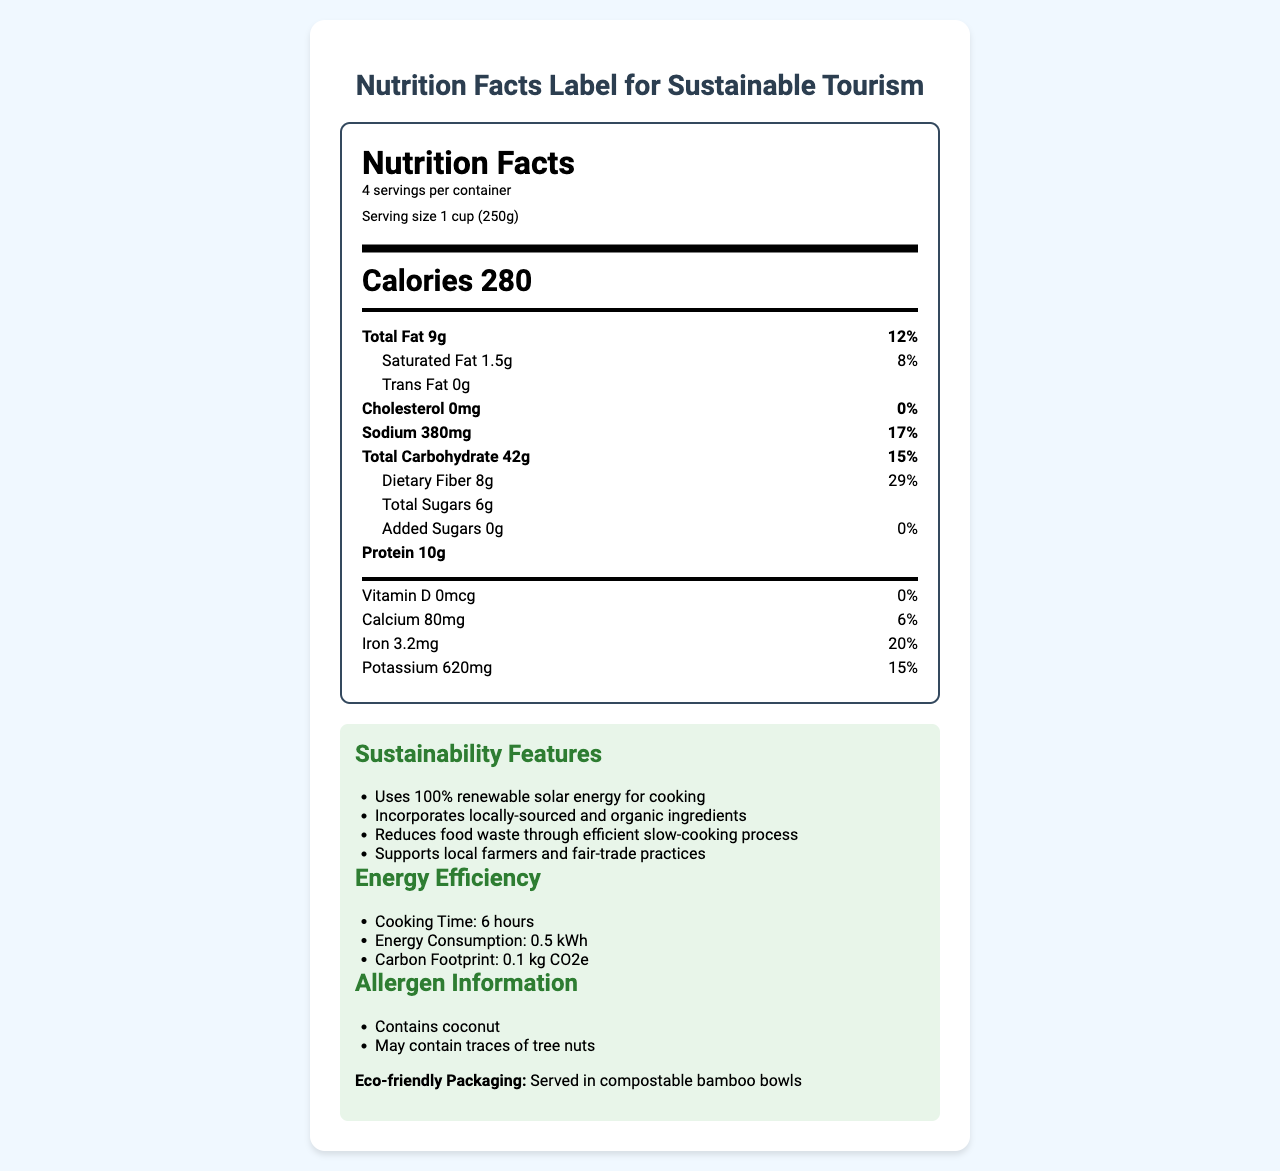How many servings are in a container? The document states there are "4 servings per container."
Answer: 4 What is the serving size for the dish? The serving size is listed as "1 cup (250g)."
Answer: 1 cup (250g) How many calories are there per serving? The document indicates "Calories 280."
Answer: 280 How much total fat is in a serving and what percentage of the daily value does it represent? The total fat content is 9g, which is 12% of the daily value.
Answer: 9g, 12% Does the dish contain any trans fat? The document lists "Trans Fat 0g," indicating there is no trans fat in the dish.
Answer: No How much dietary fiber is in a serving and what percentage of the daily value does it represent? Each serving contains 8g of dietary fiber, which is 29% of the daily value.
Answer: 8g, 29% What are the main ingredients of this dish? The main ingredients are explicitly listed in the document.
Answer: Locally-sourced sweet potatoes, Organic chickpeas, Fair-trade coconut milk, Sustainably-grown bell peppers, Organic tomatoes, Locally-grown spinach What is the cooking method used for this dish? The document mentions that the dish is cooked using a "Solar-powered slow cooker."
Answer: Solar-powered slow cooker A. Which vitamin or mineral has the highest percentage of daily value?
1) Calcium
2) Iron
3) Potassium Iron is listed at 20% of the daily value, which is higher than Calcium (6%) and Potassium (15%).
Answer: 1) Iron B. How long does it take to cook this dish using the listed method?
A. 3 hours
B. 4 hours
C. 6 hours
D. 8 hours The document specifies an "Energy Efficiency" feature with a "Cooking Time: 6 hours."
Answer: C. 6 hours Does the dish contain any added sugars? The document specifies "Added Sugars 0g," indicating no added sugars.
Answer: No Summarize the main sustainability features of this dish. The document lists multiple sustainability features, which include renewable energy use, organic and locally-sourced ingredients, efficient cooking, and eco-friendly packaging.
Answer: The dish is cooked using 100% renewable solar energy, incorporates locally-sourced and organic ingredients, reduces food waste through an efficient slow-cooking process, and supports local farmers and fair-trade practices. It is also served in compostable bamboo bowls. How much potassium is in a serving? The amount of potassium per serving is listed as 620mg in the document.
Answer: 620mg What is the carbon footprint associated with cooking one serving of this dish? The "Energy Efficiency" section of the document specifies a carbon footprint of "0.1 kg CO2e."
Answer: 0.1 kg CO2e Does the dish support local farmers? The document mentions "Supports local farmers and fair-trade practices" as one of its sustainability features.
Answer: Yes What is the percentage of daily value for sodium in each serving? The document lists the sodium content as 380mg, which is 17% of the daily value.
Answer: 17% What flavors or seasonings are used in this dish? The document does not provide specific details on the flavors or seasonings used in the dish.
Answer: Not enough information 